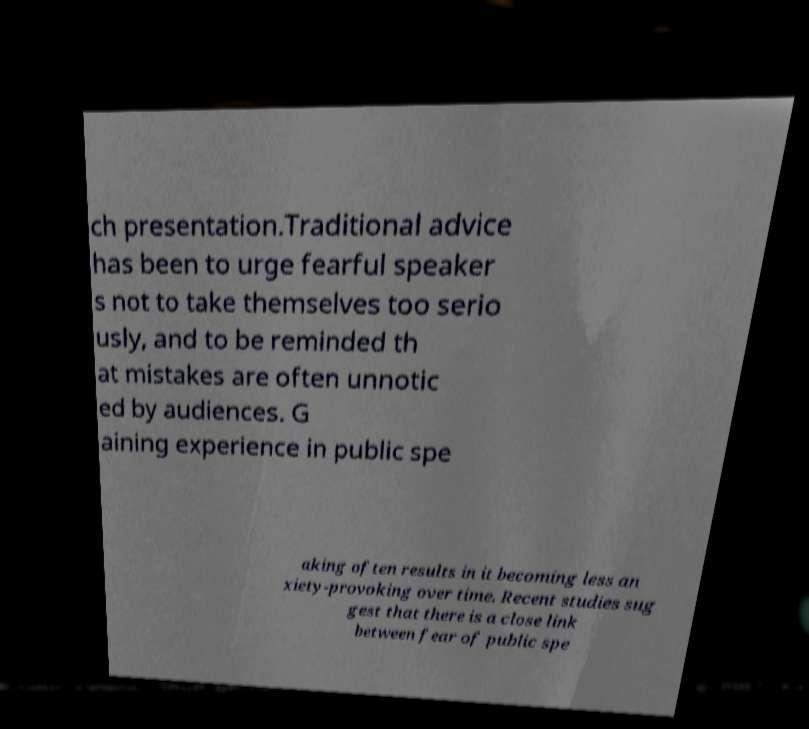Could you assist in decoding the text presented in this image and type it out clearly? ch presentation.Traditional advice has been to urge fearful speaker s not to take themselves too serio usly, and to be reminded th at mistakes are often unnotic ed by audiences. G aining experience in public spe aking often results in it becoming less an xiety-provoking over time. Recent studies sug gest that there is a close link between fear of public spe 